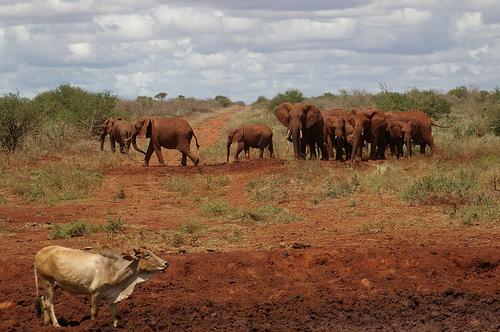What is on the ground?
Quick response, please. Dirt. Which of the two species of animals grows larger?
Write a very short answer. Elephant. What color are these elephants?
Write a very short answer. Brown. Will the elephants need to defend themselves against the other animal?
Answer briefly. No. 